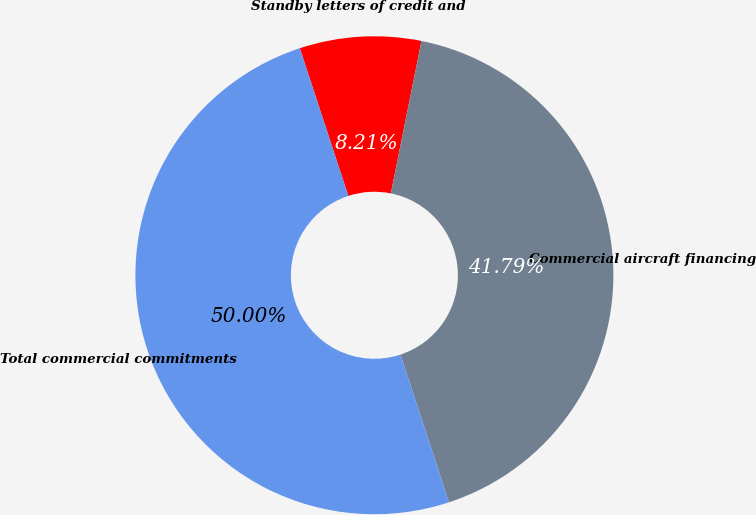<chart> <loc_0><loc_0><loc_500><loc_500><pie_chart><fcel>Standby letters of credit and<fcel>Commercial aircraft financing<fcel>Total commercial commitments<nl><fcel>8.21%<fcel>41.79%<fcel>50.0%<nl></chart> 